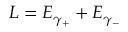Convert formula to latex. <formula><loc_0><loc_0><loc_500><loc_500>L = E _ { \gamma _ { + } } + E _ { \gamma _ { - } }</formula> 